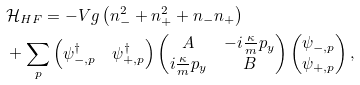Convert formula to latex. <formula><loc_0><loc_0><loc_500><loc_500>& \mathcal { H } _ { H F } = - V g \left ( n _ { - } ^ { 2 } + n _ { + } ^ { 2 } + n _ { - } n _ { + } \right ) \\ & + \sum _ { p } \begin{pmatrix} \psi ^ { \dagger } _ { - , p } & \psi ^ { \dagger } _ { + , p } \end{pmatrix} \begin{pmatrix} A & - i \frac { \kappa } { m } p _ { y } \\ i \frac { \kappa } { m } p _ { y } & B \end{pmatrix} \begin{pmatrix} \psi _ { - , p } \\ \psi _ { + , p } \end{pmatrix} ,</formula> 